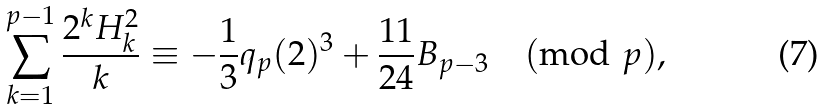Convert formula to latex. <formula><loc_0><loc_0><loc_500><loc_500>\sum _ { k = 1 } ^ { p - 1 } \frac { 2 ^ { k } H _ { k } ^ { 2 } } { k } \equiv - \frac { 1 } { 3 } q _ { p } ( 2 ) ^ { 3 } + \frac { 1 1 } { 2 4 } B _ { p - 3 } \pmod { p } ,</formula> 